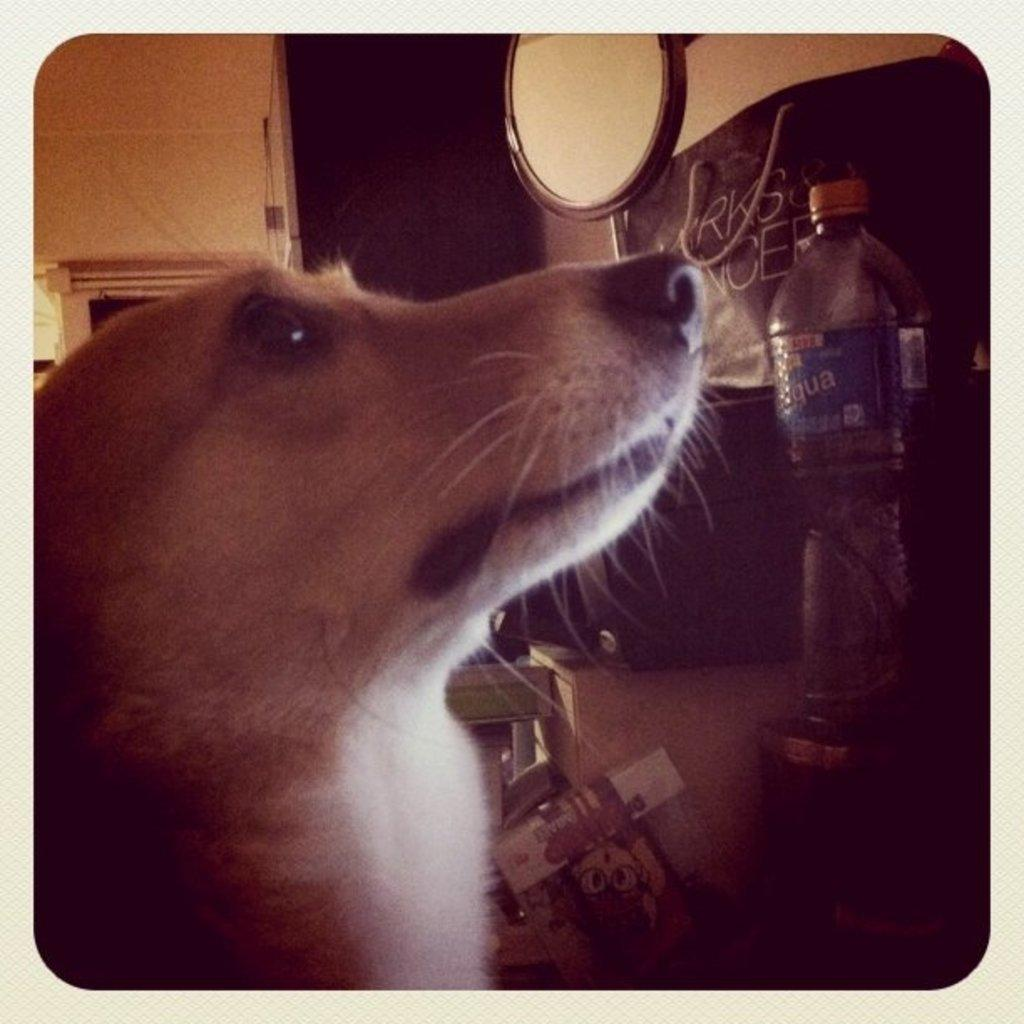What is located on the left side of the image? There is a dog's face on the left side of the image. What can be seen in the background of the image? There is a wall in the background of the image. What object is present in the image besides the dog's face and the wall? There is a bottle in the image. How is the bottle positioned in relation to other objects? The bottle is kept on another container. Where is the throne located in the image? There is no throne present in the image. What type of quiver can be seen on the dog's face in the image? There is no quiver present on the dog's face in the image. 